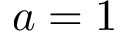<formula> <loc_0><loc_0><loc_500><loc_500>a = 1</formula> 